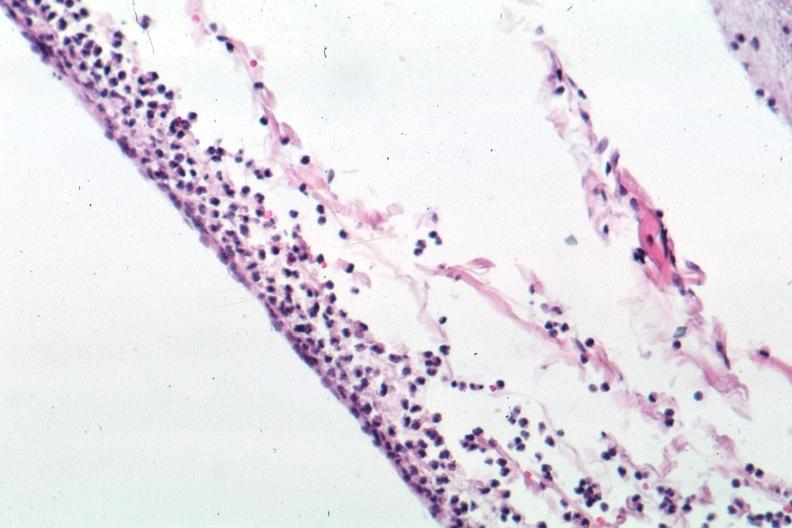what is present?
Answer the question using a single word or phrase. Brain 